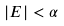Convert formula to latex. <formula><loc_0><loc_0><loc_500><loc_500>| E | < \alpha</formula> 